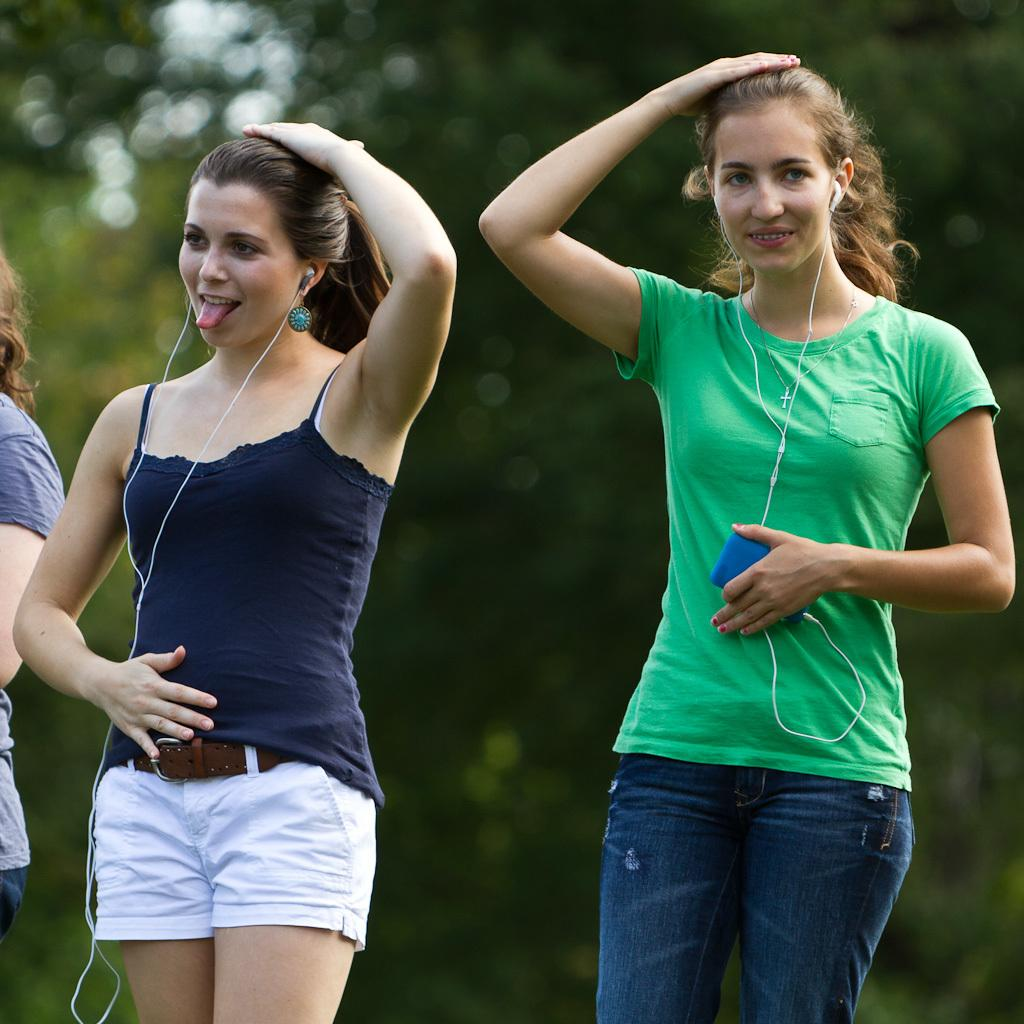What can be seen in the image? There are women standing in the image. What are the women wearing? The women are wearing headsets. What is one of the women holding? One woman is holding a device. What can be seen in the background of the image? There are trees visible in the background of the image. What type of soda is being requested by the woman in the image? There is no mention of soda or a request in the image. What paste is being used by the women in the image? There is no paste present or being used in the image. 